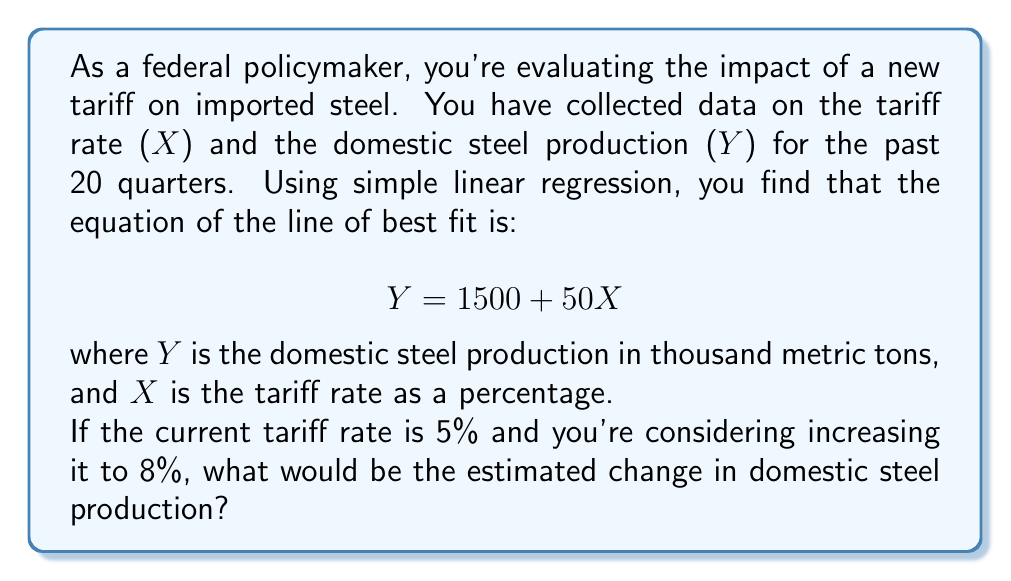Help me with this question. To solve this problem, we'll use the simple linear regression equation provided:

$$ Y = 1500 + 50X $$

Where:
- Y is the domestic steel production in thousand metric tons
- X is the tariff rate as a percentage
- 1500 is the y-intercept (base production when tariff is 0%)
- 50 is the slope (change in production for each 1% change in tariff)

We need to calculate the difference between the estimated production at 8% tariff and 5% tariff:

1. Calculate Y when X = 5% (current tariff):
   $Y_1 = 1500 + 50(5) = 1500 + 250 = 1750$ thousand metric tons

2. Calculate Y when X = 8% (proposed tariff):
   $Y_2 = 1500 + 50(8) = 1500 + 400 = 1900$ thousand metric tons

3. Calculate the difference:
   $\Delta Y = Y_2 - Y_1 = 1900 - 1750 = 150$ thousand metric tons

This means that increasing the tariff from 5% to 8% is estimated to increase domestic steel production by 150 thousand metric tons.
Answer: The estimated change in domestic steel production would be an increase of 150 thousand metric tons. 